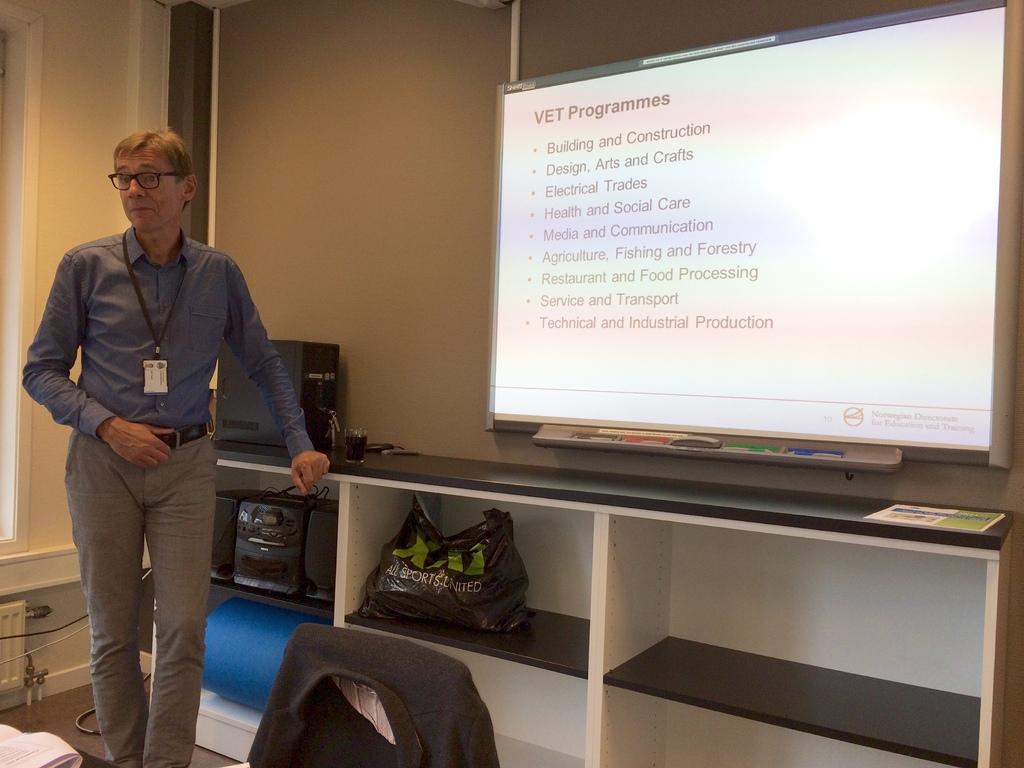Can you describe this image briefly? In this image I can see a person wearing a id card , standing in front of the bench on the bench I can see a CPU and under the bench I can see a carry bag and box kept on it. and above the bench a screen attached to the wall. 